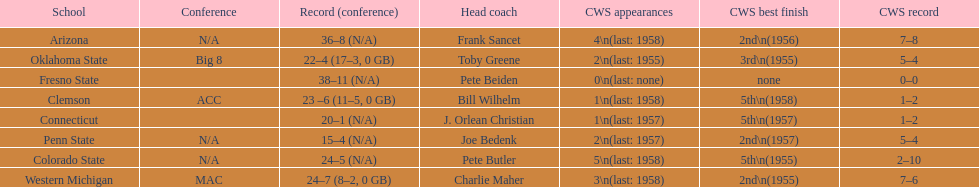Does clemson or western michigan have more cws appearances? Western Michigan. 